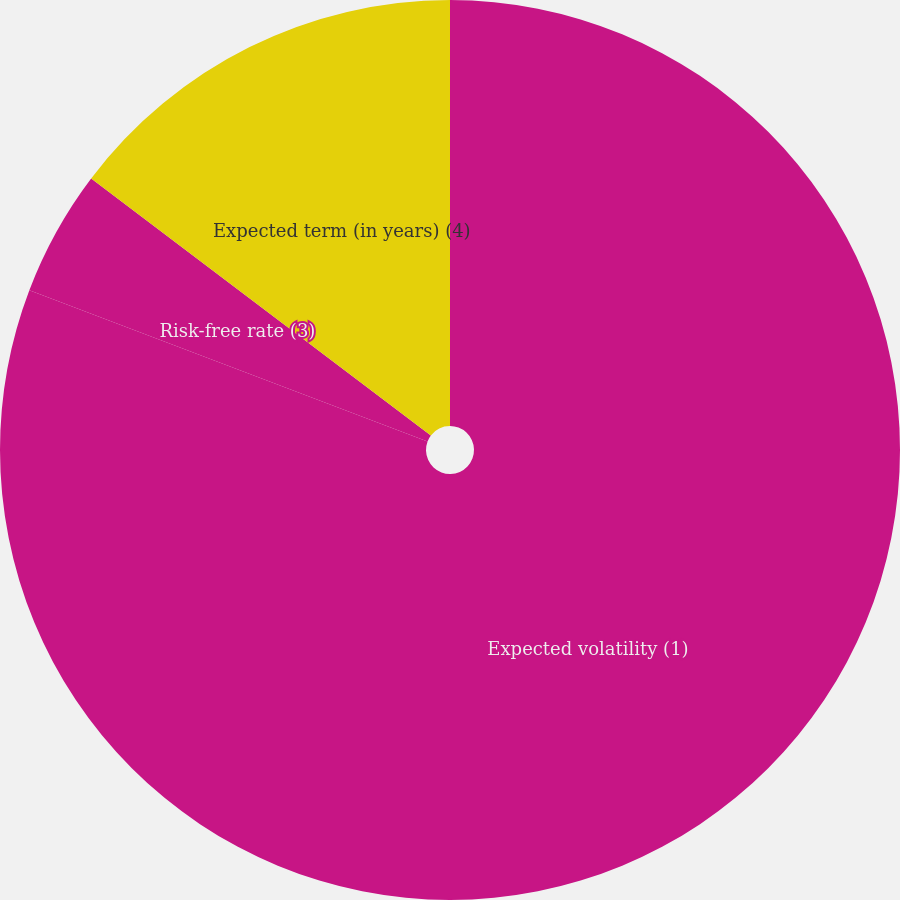Convert chart. <chart><loc_0><loc_0><loc_500><loc_500><pie_chart><fcel>Expected volatility (1)<fcel>Risk-free rate (3)<fcel>Expected term (in years) (4)<nl><fcel>80.78%<fcel>4.53%<fcel>14.69%<nl></chart> 